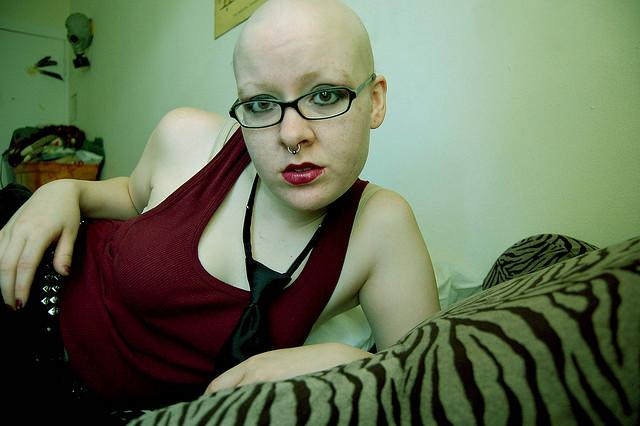What is sh doing? Please explain your reasoning. posing. She is laying on one arm with the other arm cocked over her waist. 